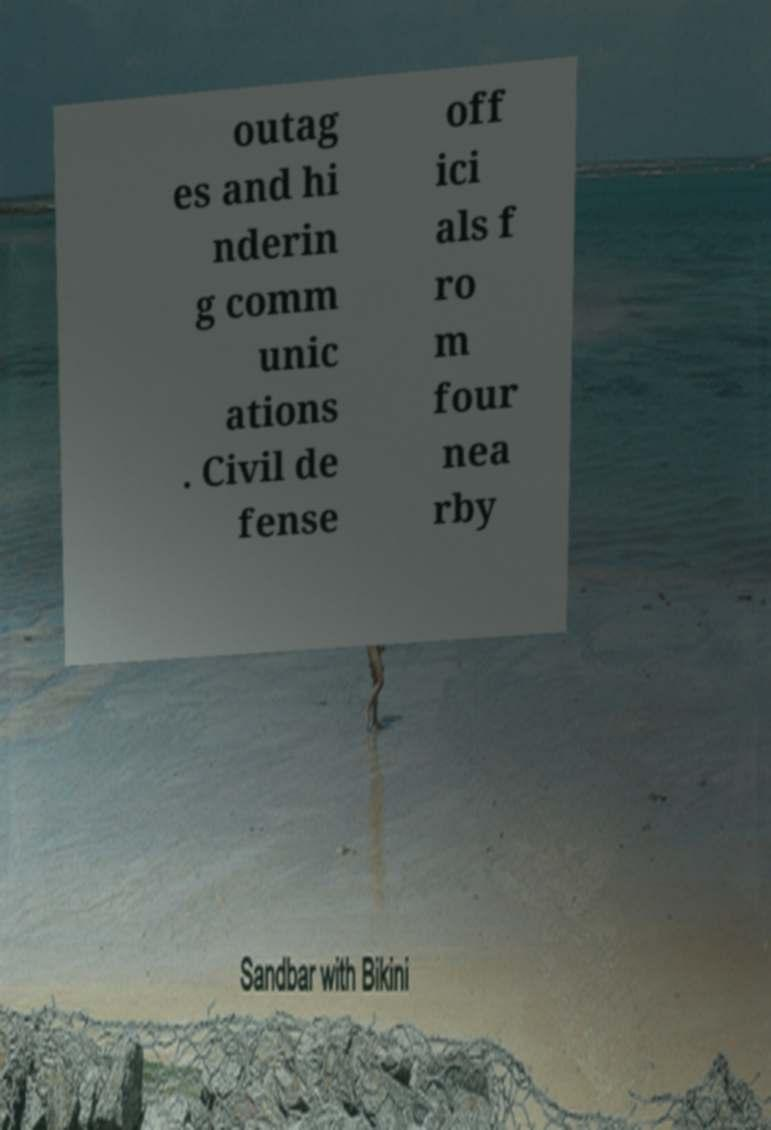I need the written content from this picture converted into text. Can you do that? outag es and hi nderin g comm unic ations . Civil de fense off ici als f ro m four nea rby 